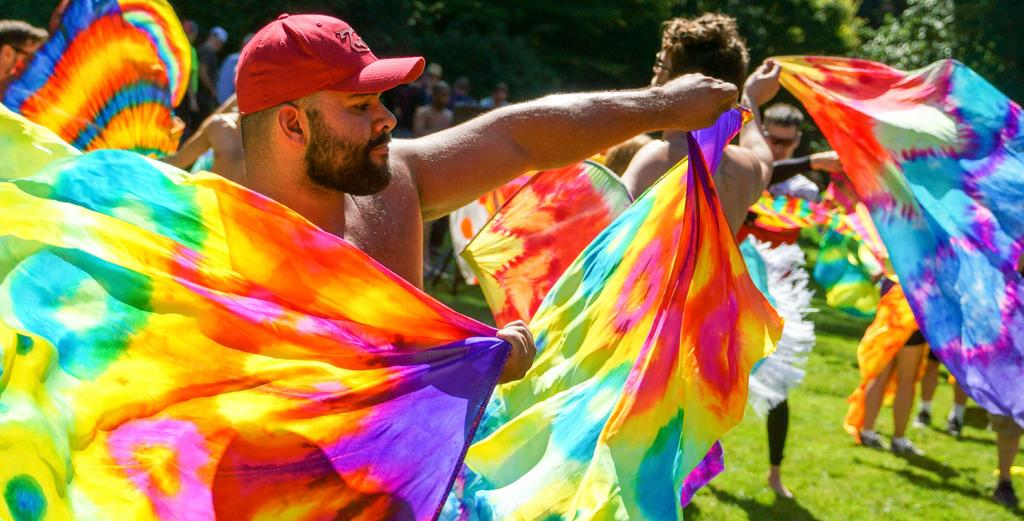What are the people in the image holding? The people in the image are holding clothes. What type of natural environment is visible in the image? There is grass visible in the image, which suggests a natural setting. What can be seen in the background of the image? There are trees and people in the background of the image. How many babies are sitting on the bridge in the image? There is no bridge or babies present in the image. What type of steam can be seen coming from the clothes in the image? There is no steam visible in the image; the people are holding clothes, but there is no indication of steam. 